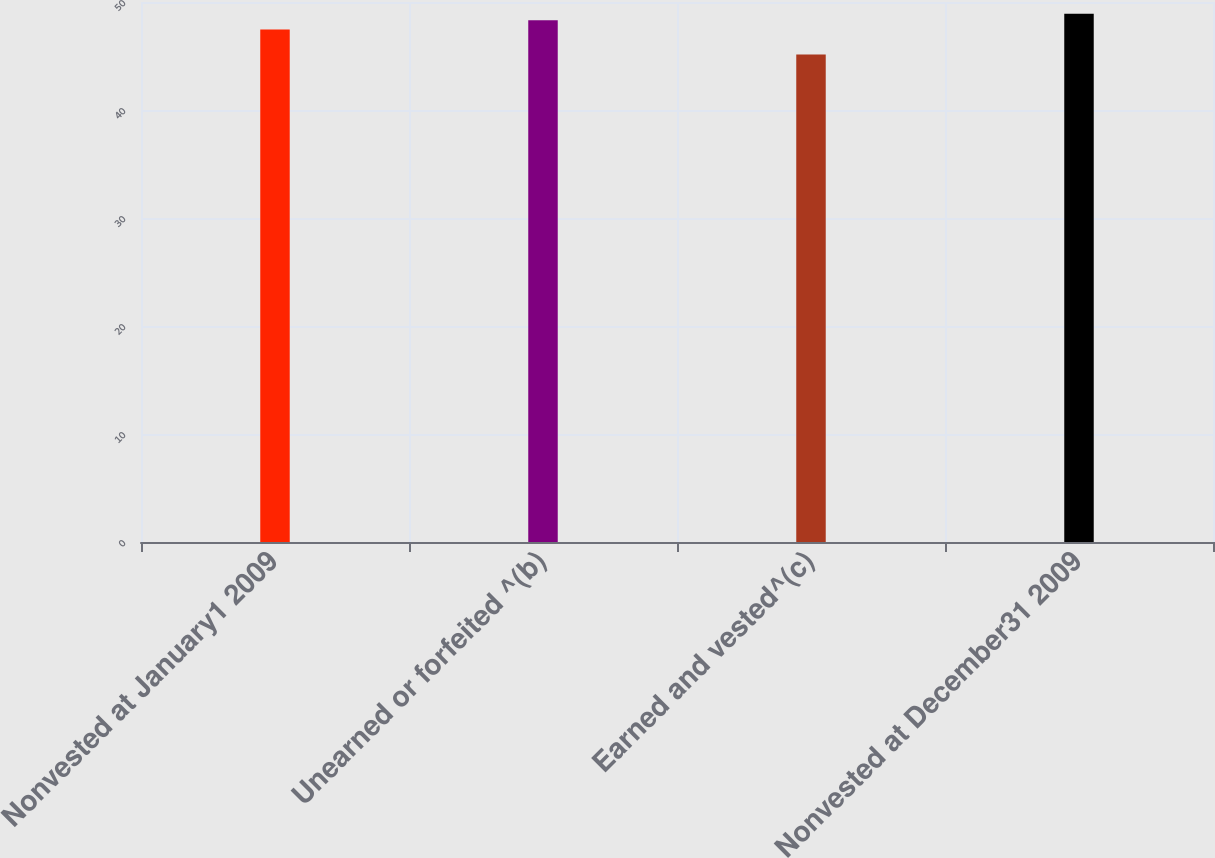Convert chart to OTSL. <chart><loc_0><loc_0><loc_500><loc_500><bar_chart><fcel>Nonvested at January1 2009<fcel>Unearned or forfeited ^(b)<fcel>Earned and vested^(c)<fcel>Nonvested at December31 2009<nl><fcel>47.46<fcel>48.3<fcel>45.15<fcel>48.92<nl></chart> 